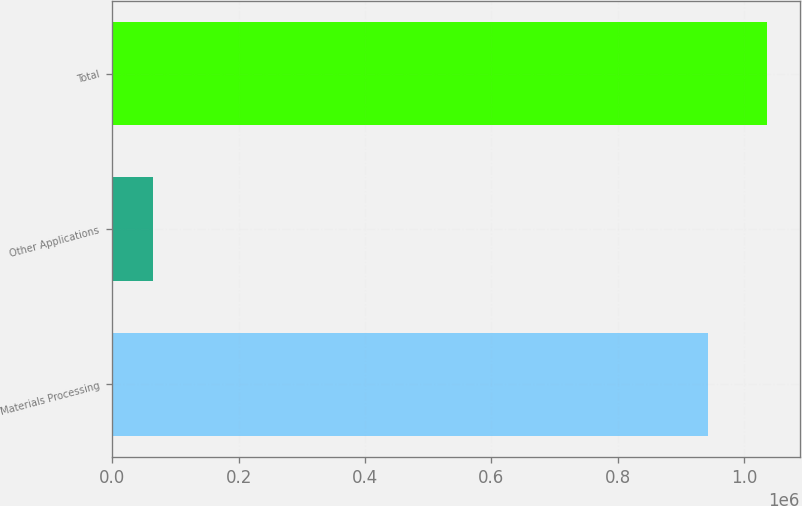<chart> <loc_0><loc_0><loc_500><loc_500><bar_chart><fcel>Materials Processing<fcel>Other Applications<fcel>Total<nl><fcel>942119<fcel>64054<fcel>1.03633e+06<nl></chart> 